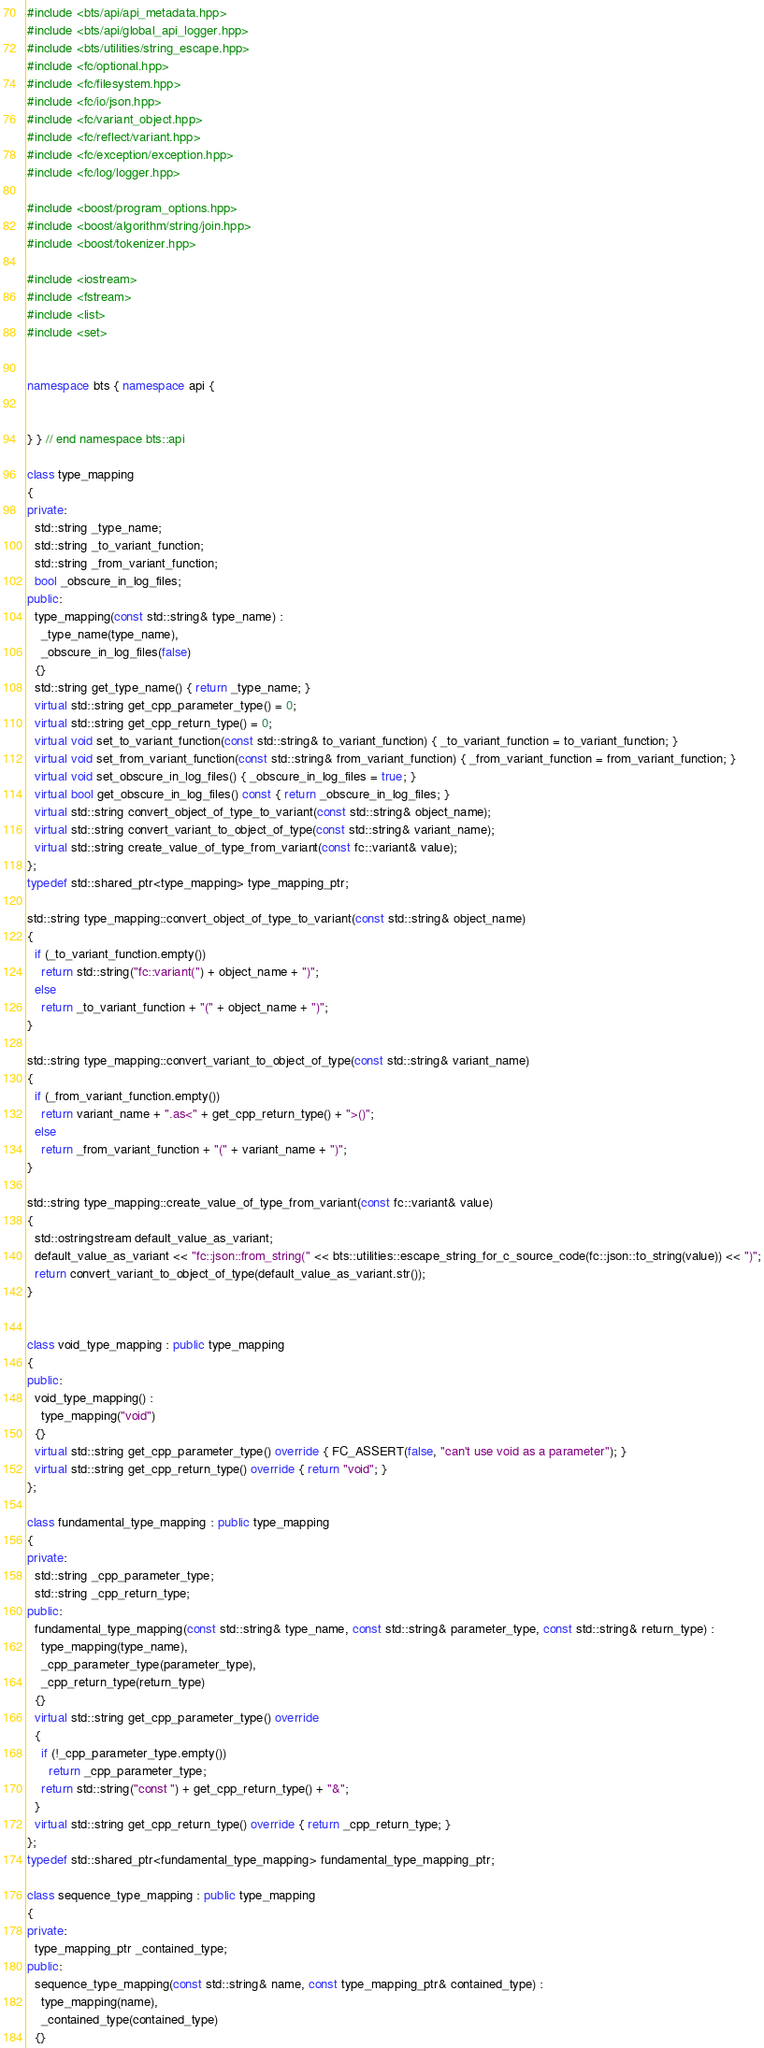<code> <loc_0><loc_0><loc_500><loc_500><_C++_>#include <bts/api/api_metadata.hpp>
#include <bts/api/global_api_logger.hpp>
#include <bts/utilities/string_escape.hpp>
#include <fc/optional.hpp>
#include <fc/filesystem.hpp>
#include <fc/io/json.hpp>
#include <fc/variant_object.hpp>
#include <fc/reflect/variant.hpp>
#include <fc/exception/exception.hpp>
#include <fc/log/logger.hpp>

#include <boost/program_options.hpp>
#include <boost/algorithm/string/join.hpp>
#include <boost/tokenizer.hpp>

#include <iostream>
#include <fstream>
#include <list>
#include <set>


namespace bts { namespace api {


} } // end namespace bts::api

class type_mapping
{
private:
  std::string _type_name;
  std::string _to_variant_function;
  std::string _from_variant_function;
  bool _obscure_in_log_files;
public:
  type_mapping(const std::string& type_name) :
    _type_name(type_name),
    _obscure_in_log_files(false)
  {}
  std::string get_type_name() { return _type_name; }
  virtual std::string get_cpp_parameter_type() = 0;
  virtual std::string get_cpp_return_type() = 0;
  virtual void set_to_variant_function(const std::string& to_variant_function) { _to_variant_function = to_variant_function; }
  virtual void set_from_variant_function(const std::string& from_variant_function) { _from_variant_function = from_variant_function; }
  virtual void set_obscure_in_log_files() { _obscure_in_log_files = true; }
  virtual bool get_obscure_in_log_files() const { return _obscure_in_log_files; }
  virtual std::string convert_object_of_type_to_variant(const std::string& object_name);
  virtual std::string convert_variant_to_object_of_type(const std::string& variant_name);
  virtual std::string create_value_of_type_from_variant(const fc::variant& value);
};
typedef std::shared_ptr<type_mapping> type_mapping_ptr;

std::string type_mapping::convert_object_of_type_to_variant(const std::string& object_name)
{
  if (_to_variant_function.empty())
    return std::string("fc::variant(") + object_name + ")";
  else
    return _to_variant_function + "(" + object_name + ")";
}

std::string type_mapping::convert_variant_to_object_of_type(const std::string& variant_name)
{
  if (_from_variant_function.empty())
    return variant_name + ".as<" + get_cpp_return_type() + ">()";
  else
    return _from_variant_function + "(" + variant_name + ")";
}

std::string type_mapping::create_value_of_type_from_variant(const fc::variant& value)
{
  std::ostringstream default_value_as_variant;
  default_value_as_variant << "fc::json::from_string(" << bts::utilities::escape_string_for_c_source_code(fc::json::to_string(value)) << ")";
  return convert_variant_to_object_of_type(default_value_as_variant.str());
}


class void_type_mapping : public type_mapping
{
public:
  void_type_mapping() :
    type_mapping("void")
  {}
  virtual std::string get_cpp_parameter_type() override { FC_ASSERT(false, "can't use void as a parameter"); }
  virtual std::string get_cpp_return_type() override { return "void"; }
};

class fundamental_type_mapping : public type_mapping
{
private:
  std::string _cpp_parameter_type;
  std::string _cpp_return_type;
public:
  fundamental_type_mapping(const std::string& type_name, const std::string& parameter_type, const std::string& return_type) :
    type_mapping(type_name),
    _cpp_parameter_type(parameter_type),
    _cpp_return_type(return_type)
  {}
  virtual std::string get_cpp_parameter_type() override
  { 
    if (!_cpp_parameter_type.empty())
      return _cpp_parameter_type;
    return std::string("const ") + get_cpp_return_type() + "&";
  }
  virtual std::string get_cpp_return_type() override { return _cpp_return_type; }
};
typedef std::shared_ptr<fundamental_type_mapping> fundamental_type_mapping_ptr;

class sequence_type_mapping : public type_mapping
{
private:
  type_mapping_ptr _contained_type;
public:
  sequence_type_mapping(const std::string& name, const type_mapping_ptr& contained_type) :
    type_mapping(name),
    _contained_type(contained_type)
  {}</code> 